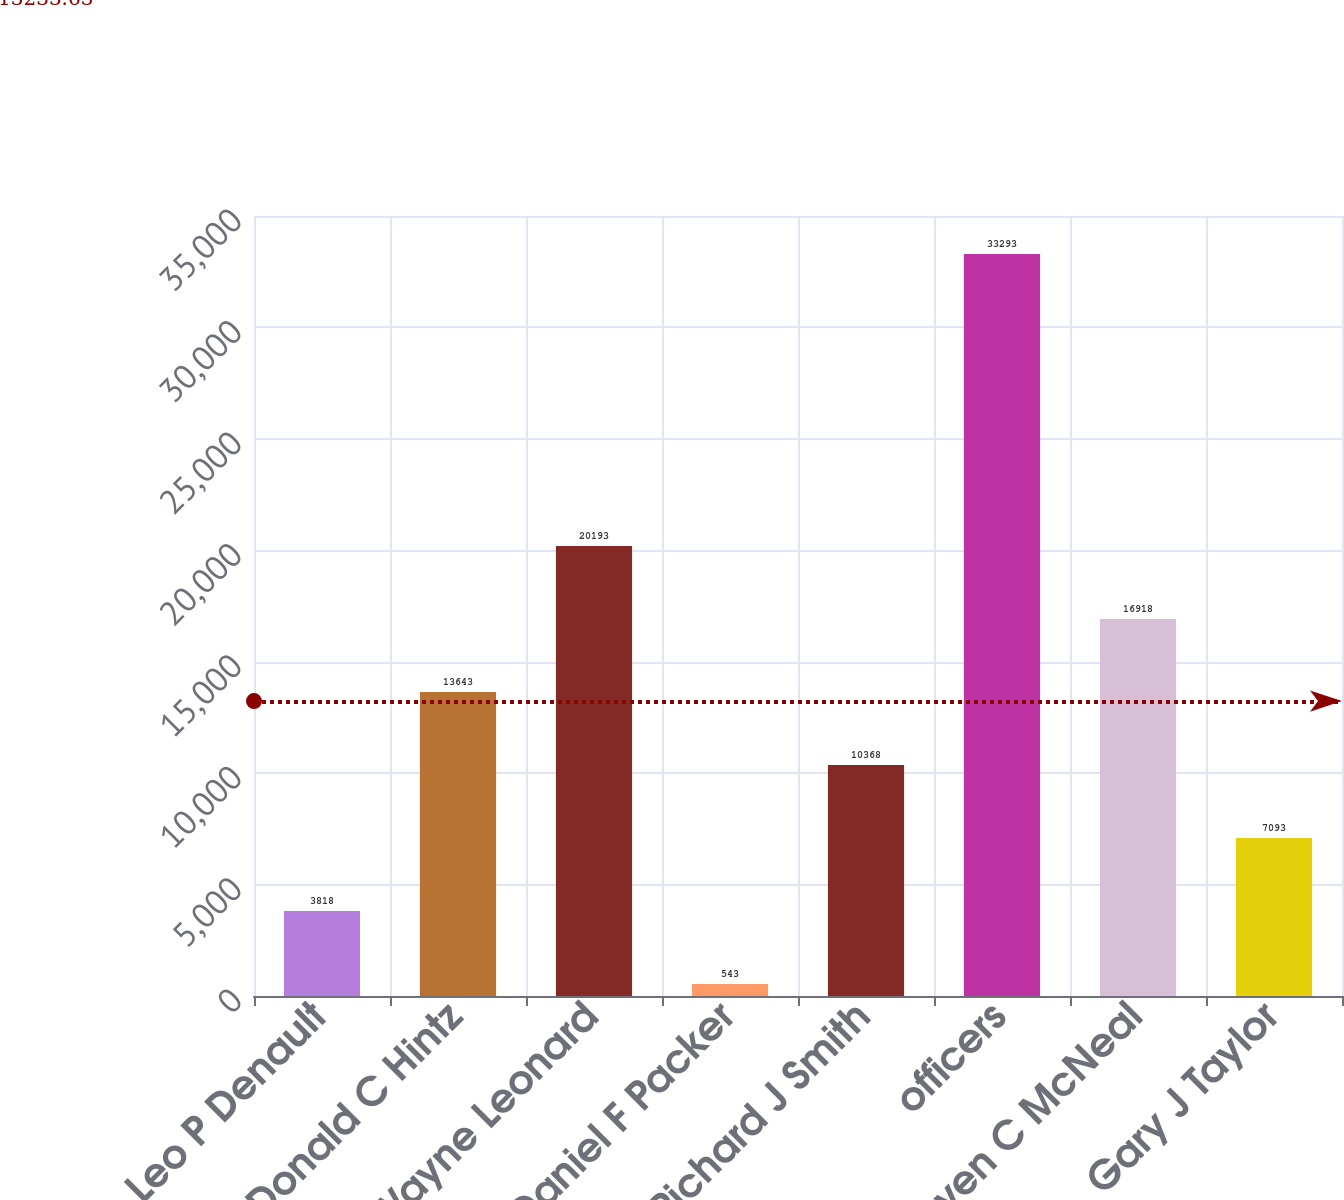<chart> <loc_0><loc_0><loc_500><loc_500><bar_chart><fcel>Leo P Denault<fcel>Donald C Hintz<fcel>J Wayne Leonard<fcel>Daniel F Packer<fcel>Richard J Smith<fcel>officers<fcel>Steven C McNeal<fcel>Gary J Taylor<nl><fcel>3818<fcel>13643<fcel>20193<fcel>543<fcel>10368<fcel>33293<fcel>16918<fcel>7093<nl></chart> 